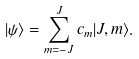Convert formula to latex. <formula><loc_0><loc_0><loc_500><loc_500>| \psi \rangle = \sum _ { m = - J } ^ { J } c _ { m } | J , m \rangle .</formula> 